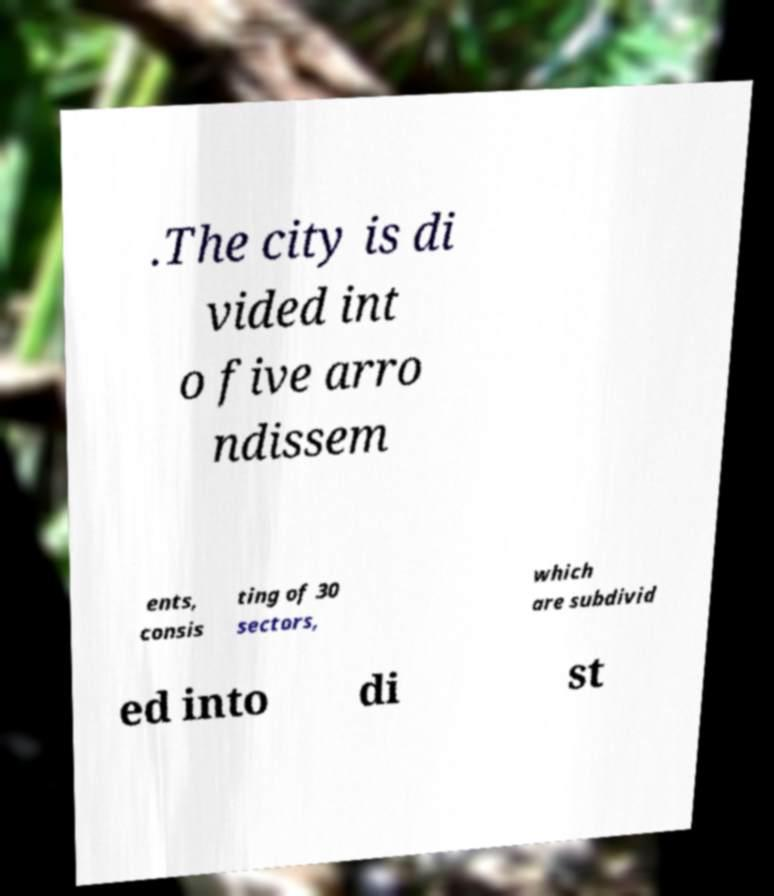Please read and relay the text visible in this image. What does it say? .The city is di vided int o five arro ndissem ents, consis ting of 30 sectors, which are subdivid ed into di st 